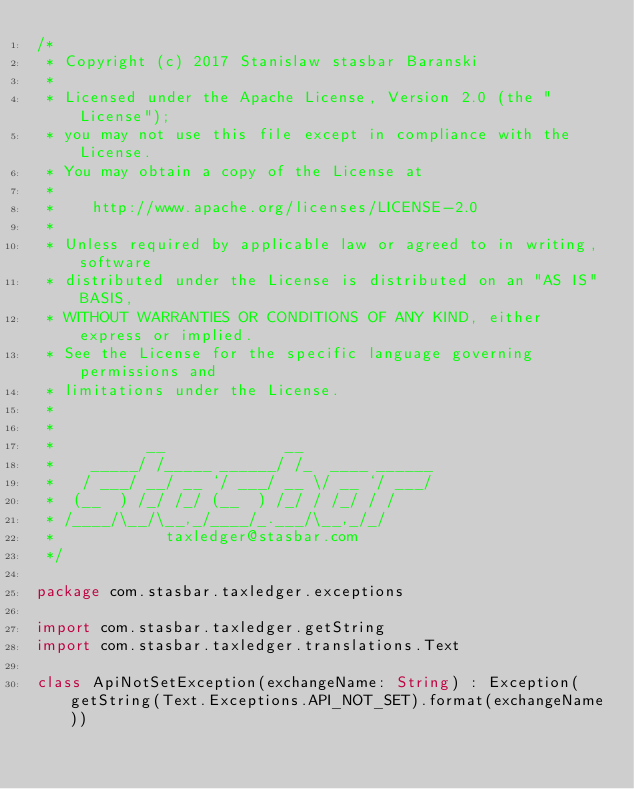Convert code to text. <code><loc_0><loc_0><loc_500><loc_500><_Kotlin_>/*
 * Copyright (c) 2017 Stanislaw stasbar Baranski
 *
 * Licensed under the Apache License, Version 2.0 (the "License");
 * you may not use this file except in compliance with the License.
 * You may obtain a copy of the License at
 *
 *    http://www.apache.org/licenses/LICENSE-2.0
 *
 * Unless required by applicable law or agreed to in writing, software
 * distributed under the License is distributed on an "AS IS" BASIS,
 * WITHOUT WARRANTIES OR CONDITIONS OF ANY KIND, either express or implied.
 * See the License for the specific language governing permissions and
 * limitations under the License.
 *
 *
 *          __             __
 *    _____/ /_____ ______/ /_  ____ ______
 *   / ___/ __/ __ `/ ___/ __ \/ __ `/ ___/
 *  (__  ) /_/ /_/ (__  ) /_/ / /_/ / /
 * /____/\__/\__,_/____/_.___/\__,_/_/
 *            taxledger@stasbar.com
 */

package com.stasbar.taxledger.exceptions

import com.stasbar.taxledger.getString
import com.stasbar.taxledger.translations.Text

class ApiNotSetException(exchangeName: String) : Exception(getString(Text.Exceptions.API_NOT_SET).format(exchangeName))</code> 